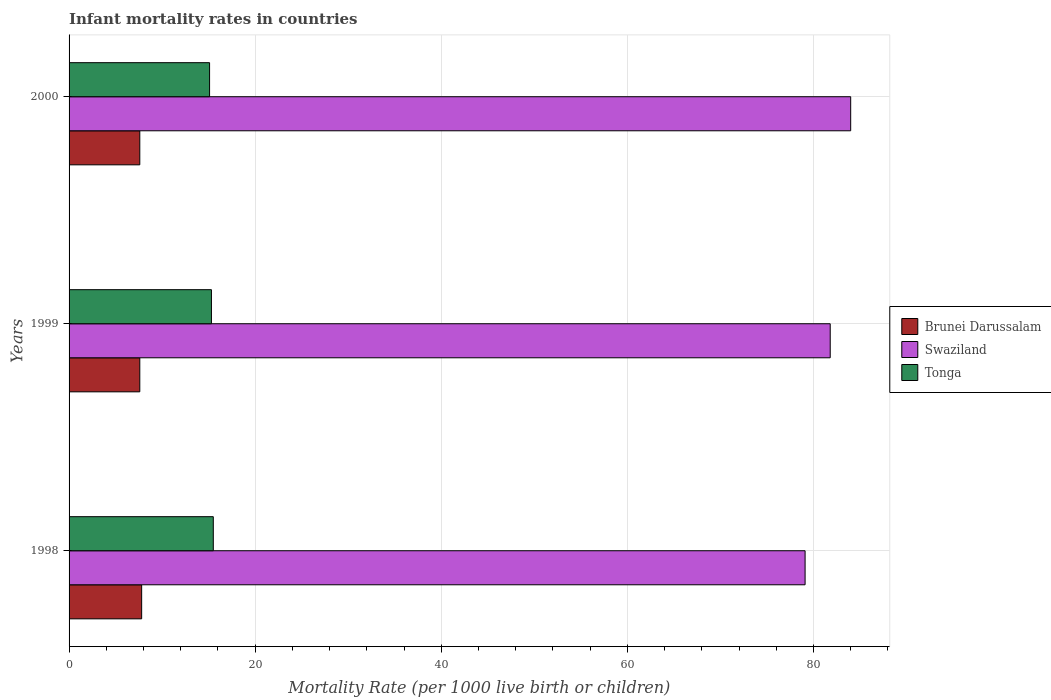How many different coloured bars are there?
Your answer should be very brief. 3. Are the number of bars per tick equal to the number of legend labels?
Make the answer very short. Yes. Are the number of bars on each tick of the Y-axis equal?
Your answer should be compact. Yes. What is the label of the 1st group of bars from the top?
Your answer should be very brief. 2000. What is the infant mortality rate in Swaziland in 2000?
Offer a terse response. 84. What is the total infant mortality rate in Brunei Darussalam in the graph?
Make the answer very short. 23. What is the difference between the infant mortality rate in Swaziland in 1998 and that in 2000?
Offer a terse response. -4.9. What is the difference between the infant mortality rate in Brunei Darussalam in 1998 and the infant mortality rate in Tonga in 1999?
Provide a short and direct response. -7.5. What is the average infant mortality rate in Swaziland per year?
Keep it short and to the point. 81.63. In the year 1998, what is the difference between the infant mortality rate in Tonga and infant mortality rate in Brunei Darussalam?
Give a very brief answer. 7.7. In how many years, is the infant mortality rate in Swaziland greater than 60 ?
Make the answer very short. 3. What is the ratio of the infant mortality rate in Swaziland in 1998 to that in 2000?
Offer a very short reply. 0.94. Is the infant mortality rate in Brunei Darussalam in 1999 less than that in 2000?
Your response must be concise. No. What is the difference between the highest and the second highest infant mortality rate in Brunei Darussalam?
Give a very brief answer. 0.2. What is the difference between the highest and the lowest infant mortality rate in Tonga?
Keep it short and to the point. 0.4. In how many years, is the infant mortality rate in Tonga greater than the average infant mortality rate in Tonga taken over all years?
Provide a short and direct response. 2. Is the sum of the infant mortality rate in Brunei Darussalam in 1998 and 2000 greater than the maximum infant mortality rate in Swaziland across all years?
Ensure brevity in your answer.  No. What does the 3rd bar from the top in 1998 represents?
Keep it short and to the point. Brunei Darussalam. What does the 2nd bar from the bottom in 2000 represents?
Give a very brief answer. Swaziland. Is it the case that in every year, the sum of the infant mortality rate in Brunei Darussalam and infant mortality rate in Swaziland is greater than the infant mortality rate in Tonga?
Your answer should be compact. Yes. Are all the bars in the graph horizontal?
Give a very brief answer. Yes. Does the graph contain any zero values?
Provide a short and direct response. No. Does the graph contain grids?
Your response must be concise. Yes. What is the title of the graph?
Your answer should be compact. Infant mortality rates in countries. Does "Sint Maarten (Dutch part)" appear as one of the legend labels in the graph?
Your answer should be very brief. No. What is the label or title of the X-axis?
Provide a succinct answer. Mortality Rate (per 1000 live birth or children). What is the label or title of the Y-axis?
Offer a very short reply. Years. What is the Mortality Rate (per 1000 live birth or children) in Swaziland in 1998?
Provide a short and direct response. 79.1. What is the Mortality Rate (per 1000 live birth or children) of Tonga in 1998?
Your response must be concise. 15.5. What is the Mortality Rate (per 1000 live birth or children) in Brunei Darussalam in 1999?
Make the answer very short. 7.6. What is the Mortality Rate (per 1000 live birth or children) of Swaziland in 1999?
Provide a short and direct response. 81.8. What is the Mortality Rate (per 1000 live birth or children) in Brunei Darussalam in 2000?
Your response must be concise. 7.6. What is the Mortality Rate (per 1000 live birth or children) of Swaziland in 2000?
Provide a succinct answer. 84. What is the Mortality Rate (per 1000 live birth or children) of Tonga in 2000?
Ensure brevity in your answer.  15.1. Across all years, what is the maximum Mortality Rate (per 1000 live birth or children) of Tonga?
Keep it short and to the point. 15.5. Across all years, what is the minimum Mortality Rate (per 1000 live birth or children) of Swaziland?
Give a very brief answer. 79.1. What is the total Mortality Rate (per 1000 live birth or children) in Swaziland in the graph?
Your answer should be compact. 244.9. What is the total Mortality Rate (per 1000 live birth or children) of Tonga in the graph?
Ensure brevity in your answer.  45.9. What is the difference between the Mortality Rate (per 1000 live birth or children) of Swaziland in 1998 and that in 2000?
Make the answer very short. -4.9. What is the difference between the Mortality Rate (per 1000 live birth or children) in Tonga in 1998 and that in 2000?
Your answer should be compact. 0.4. What is the difference between the Mortality Rate (per 1000 live birth or children) in Brunei Darussalam in 1999 and that in 2000?
Offer a terse response. 0. What is the difference between the Mortality Rate (per 1000 live birth or children) in Tonga in 1999 and that in 2000?
Ensure brevity in your answer.  0.2. What is the difference between the Mortality Rate (per 1000 live birth or children) of Brunei Darussalam in 1998 and the Mortality Rate (per 1000 live birth or children) of Swaziland in 1999?
Make the answer very short. -74. What is the difference between the Mortality Rate (per 1000 live birth or children) in Brunei Darussalam in 1998 and the Mortality Rate (per 1000 live birth or children) in Tonga in 1999?
Your response must be concise. -7.5. What is the difference between the Mortality Rate (per 1000 live birth or children) of Swaziland in 1998 and the Mortality Rate (per 1000 live birth or children) of Tonga in 1999?
Offer a very short reply. 63.8. What is the difference between the Mortality Rate (per 1000 live birth or children) in Brunei Darussalam in 1998 and the Mortality Rate (per 1000 live birth or children) in Swaziland in 2000?
Your answer should be compact. -76.2. What is the difference between the Mortality Rate (per 1000 live birth or children) of Brunei Darussalam in 1998 and the Mortality Rate (per 1000 live birth or children) of Tonga in 2000?
Your response must be concise. -7.3. What is the difference between the Mortality Rate (per 1000 live birth or children) of Swaziland in 1998 and the Mortality Rate (per 1000 live birth or children) of Tonga in 2000?
Provide a short and direct response. 64. What is the difference between the Mortality Rate (per 1000 live birth or children) of Brunei Darussalam in 1999 and the Mortality Rate (per 1000 live birth or children) of Swaziland in 2000?
Offer a terse response. -76.4. What is the difference between the Mortality Rate (per 1000 live birth or children) of Brunei Darussalam in 1999 and the Mortality Rate (per 1000 live birth or children) of Tonga in 2000?
Ensure brevity in your answer.  -7.5. What is the difference between the Mortality Rate (per 1000 live birth or children) in Swaziland in 1999 and the Mortality Rate (per 1000 live birth or children) in Tonga in 2000?
Offer a very short reply. 66.7. What is the average Mortality Rate (per 1000 live birth or children) in Brunei Darussalam per year?
Ensure brevity in your answer.  7.67. What is the average Mortality Rate (per 1000 live birth or children) of Swaziland per year?
Keep it short and to the point. 81.63. What is the average Mortality Rate (per 1000 live birth or children) of Tonga per year?
Your response must be concise. 15.3. In the year 1998, what is the difference between the Mortality Rate (per 1000 live birth or children) in Brunei Darussalam and Mortality Rate (per 1000 live birth or children) in Swaziland?
Give a very brief answer. -71.3. In the year 1998, what is the difference between the Mortality Rate (per 1000 live birth or children) in Swaziland and Mortality Rate (per 1000 live birth or children) in Tonga?
Offer a very short reply. 63.6. In the year 1999, what is the difference between the Mortality Rate (per 1000 live birth or children) in Brunei Darussalam and Mortality Rate (per 1000 live birth or children) in Swaziland?
Your answer should be very brief. -74.2. In the year 1999, what is the difference between the Mortality Rate (per 1000 live birth or children) of Brunei Darussalam and Mortality Rate (per 1000 live birth or children) of Tonga?
Provide a short and direct response. -7.7. In the year 1999, what is the difference between the Mortality Rate (per 1000 live birth or children) in Swaziland and Mortality Rate (per 1000 live birth or children) in Tonga?
Give a very brief answer. 66.5. In the year 2000, what is the difference between the Mortality Rate (per 1000 live birth or children) in Brunei Darussalam and Mortality Rate (per 1000 live birth or children) in Swaziland?
Offer a very short reply. -76.4. In the year 2000, what is the difference between the Mortality Rate (per 1000 live birth or children) of Swaziland and Mortality Rate (per 1000 live birth or children) of Tonga?
Your answer should be very brief. 68.9. What is the ratio of the Mortality Rate (per 1000 live birth or children) in Brunei Darussalam in 1998 to that in 1999?
Your answer should be very brief. 1.03. What is the ratio of the Mortality Rate (per 1000 live birth or children) in Tonga in 1998 to that in 1999?
Give a very brief answer. 1.01. What is the ratio of the Mortality Rate (per 1000 live birth or children) of Brunei Darussalam in 1998 to that in 2000?
Offer a very short reply. 1.03. What is the ratio of the Mortality Rate (per 1000 live birth or children) in Swaziland in 1998 to that in 2000?
Give a very brief answer. 0.94. What is the ratio of the Mortality Rate (per 1000 live birth or children) of Tonga in 1998 to that in 2000?
Your answer should be compact. 1.03. What is the ratio of the Mortality Rate (per 1000 live birth or children) of Swaziland in 1999 to that in 2000?
Your response must be concise. 0.97. What is the ratio of the Mortality Rate (per 1000 live birth or children) of Tonga in 1999 to that in 2000?
Your answer should be compact. 1.01. What is the difference between the highest and the second highest Mortality Rate (per 1000 live birth or children) in Brunei Darussalam?
Your answer should be very brief. 0.2. What is the difference between the highest and the second highest Mortality Rate (per 1000 live birth or children) in Swaziland?
Provide a succinct answer. 2.2. What is the difference between the highest and the lowest Mortality Rate (per 1000 live birth or children) in Brunei Darussalam?
Keep it short and to the point. 0.2. 